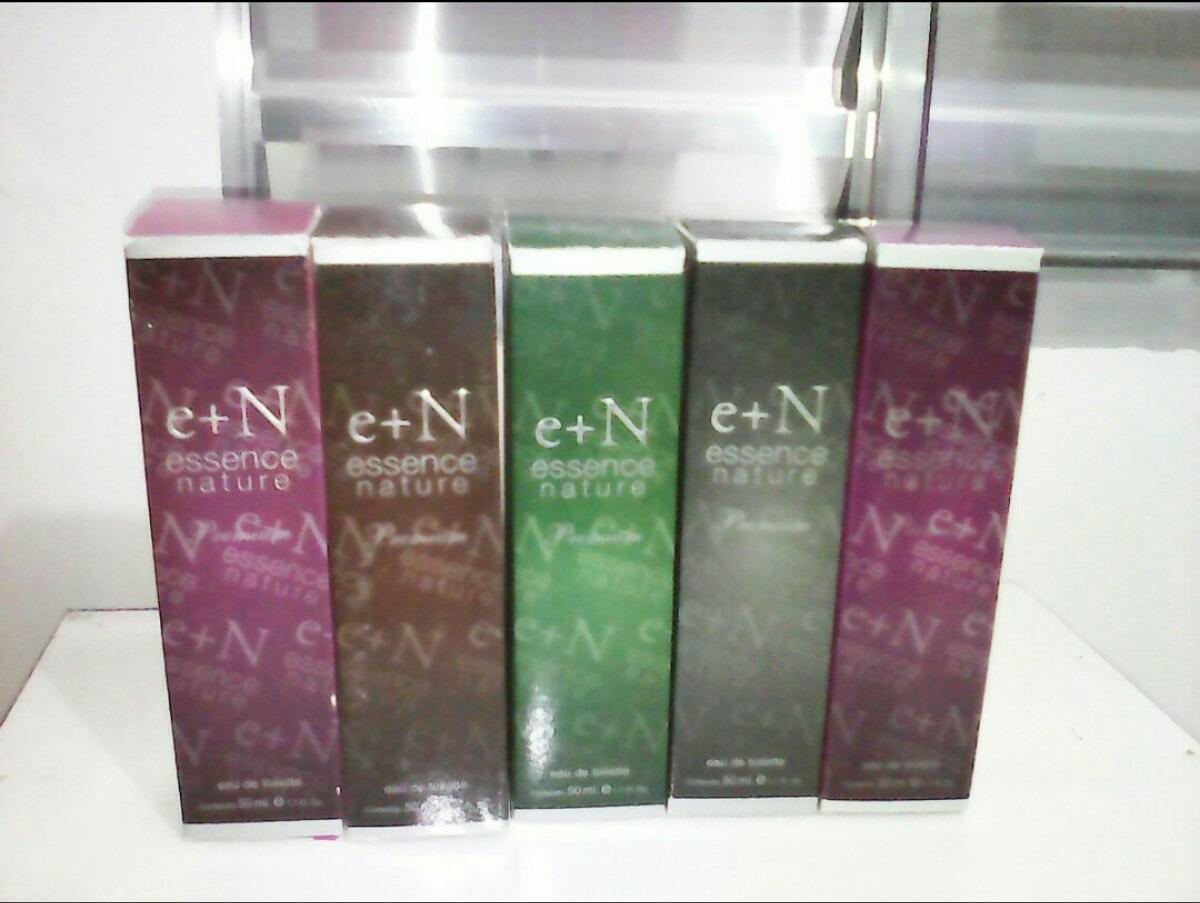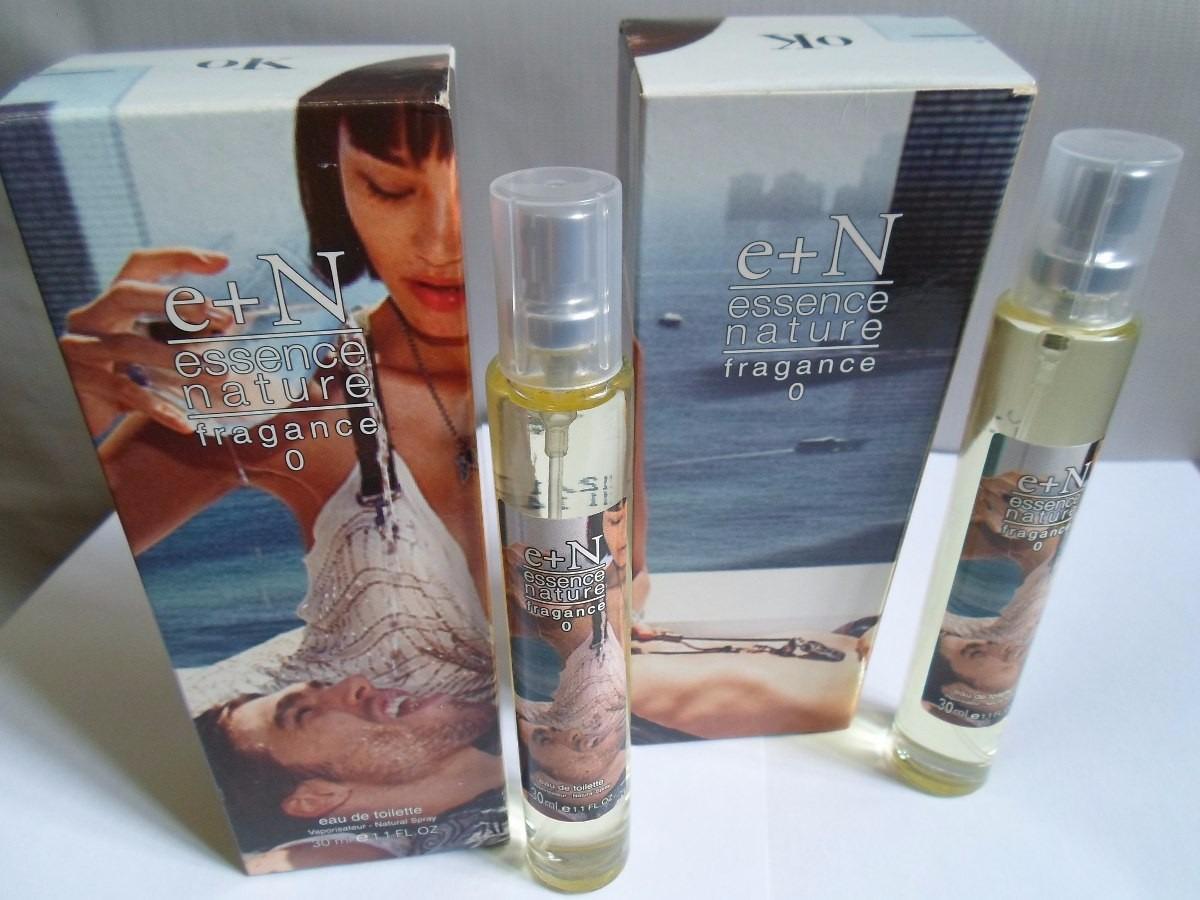The first image is the image on the left, the second image is the image on the right. For the images shown, is this caption "There are two long cylindrical perfume bottles next to their packaging box." true? Answer yes or no. Yes. The first image is the image on the left, the second image is the image on the right. For the images displayed, is the sentence "Two slender spray bottles with clear caps are shown to the right of their boxes." factually correct? Answer yes or no. Yes. 